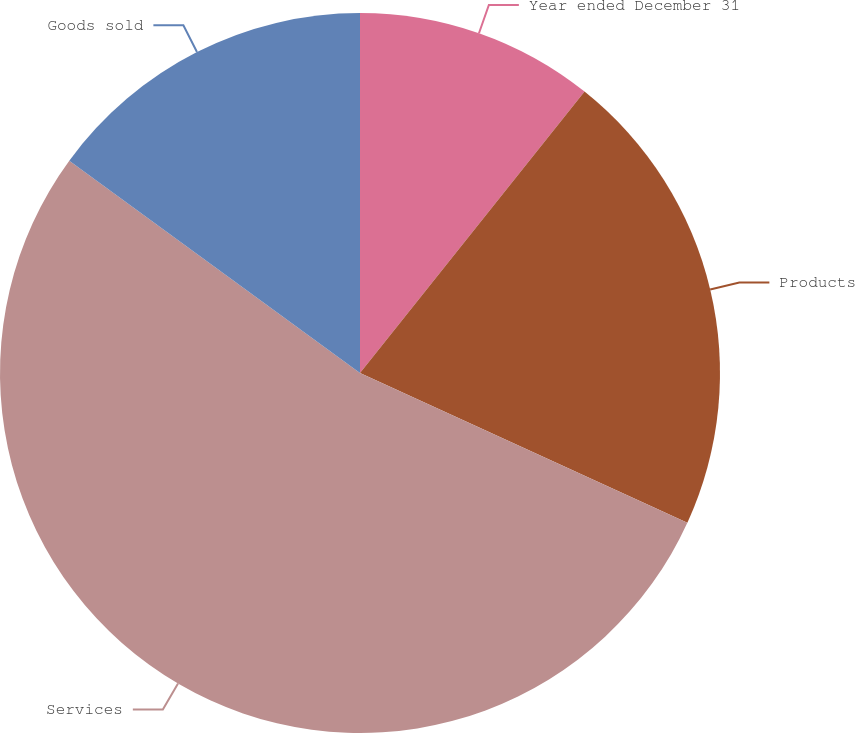Convert chart. <chart><loc_0><loc_0><loc_500><loc_500><pie_chart><fcel>Year ended December 31<fcel>Products<fcel>Services<fcel>Goods sold<nl><fcel>10.72%<fcel>21.11%<fcel>53.21%<fcel>14.96%<nl></chart> 